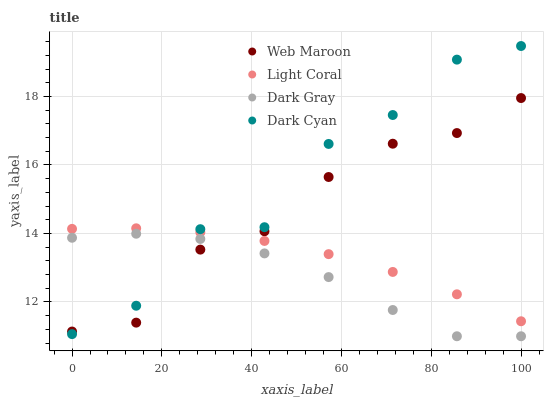Does Dark Gray have the minimum area under the curve?
Answer yes or no. Yes. Does Dark Cyan have the maximum area under the curve?
Answer yes or no. Yes. Does Web Maroon have the minimum area under the curve?
Answer yes or no. No. Does Web Maroon have the maximum area under the curve?
Answer yes or no. No. Is Light Coral the smoothest?
Answer yes or no. Yes. Is Dark Cyan the roughest?
Answer yes or no. Yes. Is Dark Gray the smoothest?
Answer yes or no. No. Is Dark Gray the roughest?
Answer yes or no. No. Does Dark Gray have the lowest value?
Answer yes or no. Yes. Does Web Maroon have the lowest value?
Answer yes or no. No. Does Dark Cyan have the highest value?
Answer yes or no. Yes. Does Web Maroon have the highest value?
Answer yes or no. No. Is Dark Gray less than Light Coral?
Answer yes or no. Yes. Is Light Coral greater than Dark Gray?
Answer yes or no. Yes. Does Dark Gray intersect Web Maroon?
Answer yes or no. Yes. Is Dark Gray less than Web Maroon?
Answer yes or no. No. Is Dark Gray greater than Web Maroon?
Answer yes or no. No. Does Dark Gray intersect Light Coral?
Answer yes or no. No. 